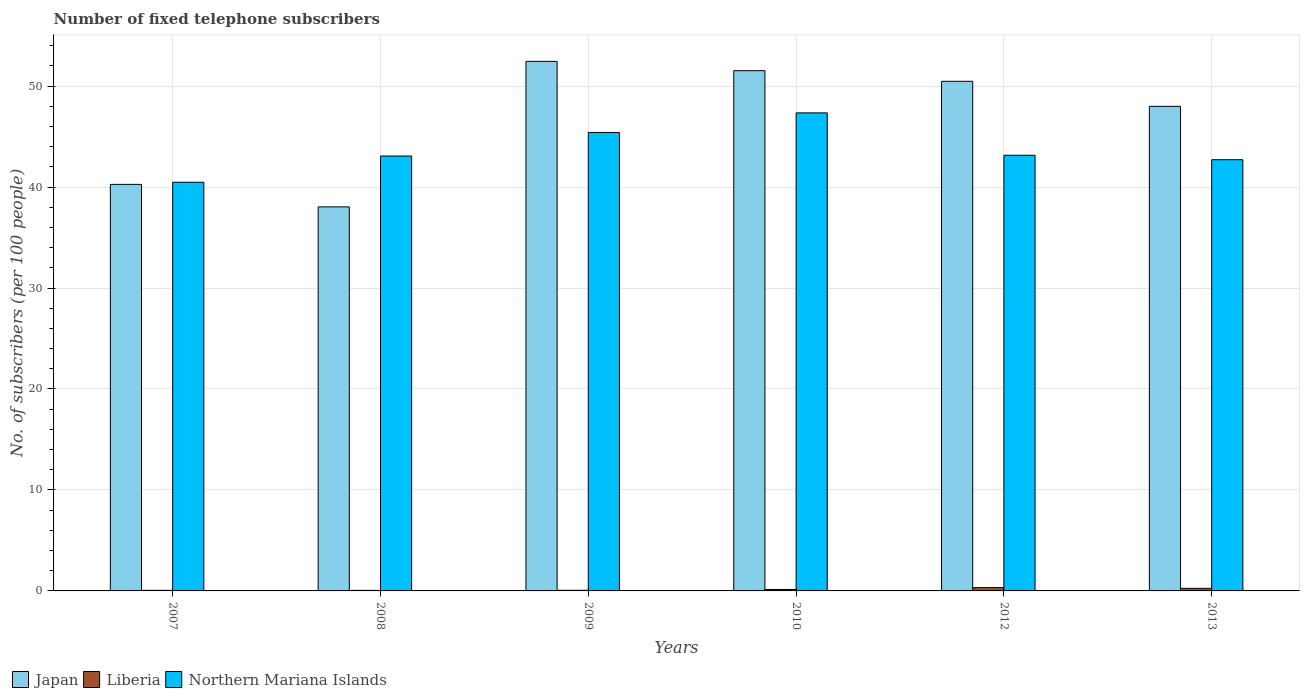How many different coloured bars are there?
Give a very brief answer. 3. How many groups of bars are there?
Make the answer very short. 6. Are the number of bars on each tick of the X-axis equal?
Keep it short and to the point. Yes. How many bars are there on the 3rd tick from the right?
Keep it short and to the point. 3. What is the number of fixed telephone subscribers in Northern Mariana Islands in 2012?
Offer a very short reply. 43.15. Across all years, what is the maximum number of fixed telephone subscribers in Japan?
Ensure brevity in your answer.  52.45. Across all years, what is the minimum number of fixed telephone subscribers in Liberia?
Provide a short and direct response. 0.05. In which year was the number of fixed telephone subscribers in Japan maximum?
Your response must be concise. 2009. In which year was the number of fixed telephone subscribers in Japan minimum?
Your response must be concise. 2008. What is the total number of fixed telephone subscribers in Liberia in the graph?
Provide a short and direct response. 0.91. What is the difference between the number of fixed telephone subscribers in Japan in 2007 and that in 2008?
Offer a very short reply. 2.23. What is the difference between the number of fixed telephone subscribers in Liberia in 2008 and the number of fixed telephone subscribers in Northern Mariana Islands in 2009?
Provide a short and direct response. -45.35. What is the average number of fixed telephone subscribers in Liberia per year?
Offer a very short reply. 0.15. In the year 2010, what is the difference between the number of fixed telephone subscribers in Japan and number of fixed telephone subscribers in Northern Mariana Islands?
Your answer should be compact. 4.18. In how many years, is the number of fixed telephone subscribers in Japan greater than 18?
Keep it short and to the point. 6. What is the ratio of the number of fixed telephone subscribers in Northern Mariana Islands in 2007 to that in 2010?
Make the answer very short. 0.85. Is the number of fixed telephone subscribers in Northern Mariana Islands in 2008 less than that in 2009?
Your response must be concise. Yes. Is the difference between the number of fixed telephone subscribers in Japan in 2008 and 2010 greater than the difference between the number of fixed telephone subscribers in Northern Mariana Islands in 2008 and 2010?
Provide a short and direct response. No. What is the difference between the highest and the second highest number of fixed telephone subscribers in Japan?
Offer a very short reply. 0.92. What is the difference between the highest and the lowest number of fixed telephone subscribers in Northern Mariana Islands?
Offer a terse response. 6.87. In how many years, is the number of fixed telephone subscribers in Japan greater than the average number of fixed telephone subscribers in Japan taken over all years?
Ensure brevity in your answer.  4. Is the sum of the number of fixed telephone subscribers in Northern Mariana Islands in 2008 and 2012 greater than the maximum number of fixed telephone subscribers in Japan across all years?
Provide a short and direct response. Yes. What does the 2nd bar from the left in 2012 represents?
Provide a short and direct response. Liberia. What does the 2nd bar from the right in 2007 represents?
Give a very brief answer. Liberia. Are all the bars in the graph horizontal?
Provide a succinct answer. No. What is the difference between two consecutive major ticks on the Y-axis?
Offer a very short reply. 10. Does the graph contain grids?
Make the answer very short. Yes. Where does the legend appear in the graph?
Your response must be concise. Bottom left. How are the legend labels stacked?
Give a very brief answer. Horizontal. What is the title of the graph?
Your answer should be very brief. Number of fixed telephone subscribers. What is the label or title of the Y-axis?
Your response must be concise. No. of subscribers (per 100 people). What is the No. of subscribers (per 100 people) in Japan in 2007?
Your answer should be compact. 40.26. What is the No. of subscribers (per 100 people) in Liberia in 2007?
Offer a very short reply. 0.06. What is the No. of subscribers (per 100 people) of Northern Mariana Islands in 2007?
Your answer should be compact. 40.47. What is the No. of subscribers (per 100 people) of Japan in 2008?
Make the answer very short. 38.04. What is the No. of subscribers (per 100 people) in Liberia in 2008?
Keep it short and to the point. 0.05. What is the No. of subscribers (per 100 people) of Northern Mariana Islands in 2008?
Your answer should be very brief. 43.07. What is the No. of subscribers (per 100 people) of Japan in 2009?
Keep it short and to the point. 52.45. What is the No. of subscribers (per 100 people) in Liberia in 2009?
Offer a very short reply. 0.06. What is the No. of subscribers (per 100 people) of Northern Mariana Islands in 2009?
Provide a succinct answer. 45.41. What is the No. of subscribers (per 100 people) in Japan in 2010?
Give a very brief answer. 51.53. What is the No. of subscribers (per 100 people) in Liberia in 2010?
Your response must be concise. 0.15. What is the No. of subscribers (per 100 people) in Northern Mariana Islands in 2010?
Your answer should be very brief. 47.34. What is the No. of subscribers (per 100 people) in Japan in 2012?
Offer a very short reply. 50.47. What is the No. of subscribers (per 100 people) in Liberia in 2012?
Your answer should be compact. 0.33. What is the No. of subscribers (per 100 people) in Northern Mariana Islands in 2012?
Keep it short and to the point. 43.15. What is the No. of subscribers (per 100 people) in Japan in 2013?
Your response must be concise. 47.99. What is the No. of subscribers (per 100 people) of Liberia in 2013?
Offer a terse response. 0.26. What is the No. of subscribers (per 100 people) in Northern Mariana Islands in 2013?
Your answer should be very brief. 42.71. Across all years, what is the maximum No. of subscribers (per 100 people) in Japan?
Your answer should be very brief. 52.45. Across all years, what is the maximum No. of subscribers (per 100 people) in Liberia?
Make the answer very short. 0.33. Across all years, what is the maximum No. of subscribers (per 100 people) in Northern Mariana Islands?
Your answer should be very brief. 47.34. Across all years, what is the minimum No. of subscribers (per 100 people) in Japan?
Offer a terse response. 38.04. Across all years, what is the minimum No. of subscribers (per 100 people) in Liberia?
Offer a very short reply. 0.05. Across all years, what is the minimum No. of subscribers (per 100 people) of Northern Mariana Islands?
Keep it short and to the point. 40.47. What is the total No. of subscribers (per 100 people) in Japan in the graph?
Offer a terse response. 280.74. What is the total No. of subscribers (per 100 people) of Liberia in the graph?
Your answer should be very brief. 0.91. What is the total No. of subscribers (per 100 people) of Northern Mariana Islands in the graph?
Keep it short and to the point. 262.15. What is the difference between the No. of subscribers (per 100 people) of Japan in 2007 and that in 2008?
Offer a very short reply. 2.23. What is the difference between the No. of subscribers (per 100 people) in Liberia in 2007 and that in 2008?
Offer a very short reply. 0. What is the difference between the No. of subscribers (per 100 people) of Northern Mariana Islands in 2007 and that in 2008?
Provide a succinct answer. -2.6. What is the difference between the No. of subscribers (per 100 people) in Japan in 2007 and that in 2009?
Ensure brevity in your answer.  -12.18. What is the difference between the No. of subscribers (per 100 people) of Liberia in 2007 and that in 2009?
Make the answer very short. -0. What is the difference between the No. of subscribers (per 100 people) of Northern Mariana Islands in 2007 and that in 2009?
Give a very brief answer. -4.93. What is the difference between the No. of subscribers (per 100 people) in Japan in 2007 and that in 2010?
Your answer should be very brief. -11.26. What is the difference between the No. of subscribers (per 100 people) of Liberia in 2007 and that in 2010?
Offer a terse response. -0.09. What is the difference between the No. of subscribers (per 100 people) in Northern Mariana Islands in 2007 and that in 2010?
Your answer should be compact. -6.87. What is the difference between the No. of subscribers (per 100 people) of Japan in 2007 and that in 2012?
Ensure brevity in your answer.  -10.21. What is the difference between the No. of subscribers (per 100 people) of Liberia in 2007 and that in 2012?
Provide a short and direct response. -0.27. What is the difference between the No. of subscribers (per 100 people) of Northern Mariana Islands in 2007 and that in 2012?
Your answer should be very brief. -2.67. What is the difference between the No. of subscribers (per 100 people) in Japan in 2007 and that in 2013?
Offer a terse response. -7.73. What is the difference between the No. of subscribers (per 100 people) in Liberia in 2007 and that in 2013?
Keep it short and to the point. -0.2. What is the difference between the No. of subscribers (per 100 people) in Northern Mariana Islands in 2007 and that in 2013?
Offer a terse response. -2.23. What is the difference between the No. of subscribers (per 100 people) in Japan in 2008 and that in 2009?
Your response must be concise. -14.41. What is the difference between the No. of subscribers (per 100 people) of Liberia in 2008 and that in 2009?
Give a very brief answer. -0.01. What is the difference between the No. of subscribers (per 100 people) of Northern Mariana Islands in 2008 and that in 2009?
Make the answer very short. -2.33. What is the difference between the No. of subscribers (per 100 people) of Japan in 2008 and that in 2010?
Offer a terse response. -13.49. What is the difference between the No. of subscribers (per 100 people) in Liberia in 2008 and that in 2010?
Your response must be concise. -0.09. What is the difference between the No. of subscribers (per 100 people) of Northern Mariana Islands in 2008 and that in 2010?
Provide a succinct answer. -4.27. What is the difference between the No. of subscribers (per 100 people) of Japan in 2008 and that in 2012?
Keep it short and to the point. -12.44. What is the difference between the No. of subscribers (per 100 people) of Liberia in 2008 and that in 2012?
Your answer should be compact. -0.27. What is the difference between the No. of subscribers (per 100 people) in Northern Mariana Islands in 2008 and that in 2012?
Keep it short and to the point. -0.08. What is the difference between the No. of subscribers (per 100 people) of Japan in 2008 and that in 2013?
Offer a terse response. -9.96. What is the difference between the No. of subscribers (per 100 people) in Liberia in 2008 and that in 2013?
Your answer should be compact. -0.2. What is the difference between the No. of subscribers (per 100 people) in Northern Mariana Islands in 2008 and that in 2013?
Provide a short and direct response. 0.37. What is the difference between the No. of subscribers (per 100 people) of Japan in 2009 and that in 2010?
Your response must be concise. 0.92. What is the difference between the No. of subscribers (per 100 people) in Liberia in 2009 and that in 2010?
Ensure brevity in your answer.  -0.08. What is the difference between the No. of subscribers (per 100 people) in Northern Mariana Islands in 2009 and that in 2010?
Your response must be concise. -1.94. What is the difference between the No. of subscribers (per 100 people) of Japan in 2009 and that in 2012?
Your response must be concise. 1.98. What is the difference between the No. of subscribers (per 100 people) in Liberia in 2009 and that in 2012?
Your answer should be very brief. -0.27. What is the difference between the No. of subscribers (per 100 people) in Northern Mariana Islands in 2009 and that in 2012?
Make the answer very short. 2.26. What is the difference between the No. of subscribers (per 100 people) of Japan in 2009 and that in 2013?
Your answer should be compact. 4.46. What is the difference between the No. of subscribers (per 100 people) of Liberia in 2009 and that in 2013?
Ensure brevity in your answer.  -0.19. What is the difference between the No. of subscribers (per 100 people) in Northern Mariana Islands in 2009 and that in 2013?
Keep it short and to the point. 2.7. What is the difference between the No. of subscribers (per 100 people) of Japan in 2010 and that in 2012?
Offer a terse response. 1.05. What is the difference between the No. of subscribers (per 100 people) in Liberia in 2010 and that in 2012?
Offer a very short reply. -0.18. What is the difference between the No. of subscribers (per 100 people) of Northern Mariana Islands in 2010 and that in 2012?
Keep it short and to the point. 4.2. What is the difference between the No. of subscribers (per 100 people) in Japan in 2010 and that in 2013?
Give a very brief answer. 3.53. What is the difference between the No. of subscribers (per 100 people) of Liberia in 2010 and that in 2013?
Your answer should be compact. -0.11. What is the difference between the No. of subscribers (per 100 people) in Northern Mariana Islands in 2010 and that in 2013?
Your response must be concise. 4.64. What is the difference between the No. of subscribers (per 100 people) of Japan in 2012 and that in 2013?
Ensure brevity in your answer.  2.48. What is the difference between the No. of subscribers (per 100 people) in Liberia in 2012 and that in 2013?
Make the answer very short. 0.07. What is the difference between the No. of subscribers (per 100 people) in Northern Mariana Islands in 2012 and that in 2013?
Your answer should be very brief. 0.44. What is the difference between the No. of subscribers (per 100 people) in Japan in 2007 and the No. of subscribers (per 100 people) in Liberia in 2008?
Ensure brevity in your answer.  40.21. What is the difference between the No. of subscribers (per 100 people) in Japan in 2007 and the No. of subscribers (per 100 people) in Northern Mariana Islands in 2008?
Provide a succinct answer. -2.81. What is the difference between the No. of subscribers (per 100 people) of Liberia in 2007 and the No. of subscribers (per 100 people) of Northern Mariana Islands in 2008?
Make the answer very short. -43.01. What is the difference between the No. of subscribers (per 100 people) in Japan in 2007 and the No. of subscribers (per 100 people) in Liberia in 2009?
Keep it short and to the point. 40.2. What is the difference between the No. of subscribers (per 100 people) of Japan in 2007 and the No. of subscribers (per 100 people) of Northern Mariana Islands in 2009?
Ensure brevity in your answer.  -5.14. What is the difference between the No. of subscribers (per 100 people) of Liberia in 2007 and the No. of subscribers (per 100 people) of Northern Mariana Islands in 2009?
Your answer should be very brief. -45.35. What is the difference between the No. of subscribers (per 100 people) in Japan in 2007 and the No. of subscribers (per 100 people) in Liberia in 2010?
Offer a very short reply. 40.12. What is the difference between the No. of subscribers (per 100 people) in Japan in 2007 and the No. of subscribers (per 100 people) in Northern Mariana Islands in 2010?
Keep it short and to the point. -7.08. What is the difference between the No. of subscribers (per 100 people) of Liberia in 2007 and the No. of subscribers (per 100 people) of Northern Mariana Islands in 2010?
Your answer should be compact. -47.29. What is the difference between the No. of subscribers (per 100 people) in Japan in 2007 and the No. of subscribers (per 100 people) in Liberia in 2012?
Your response must be concise. 39.94. What is the difference between the No. of subscribers (per 100 people) in Japan in 2007 and the No. of subscribers (per 100 people) in Northern Mariana Islands in 2012?
Offer a terse response. -2.88. What is the difference between the No. of subscribers (per 100 people) of Liberia in 2007 and the No. of subscribers (per 100 people) of Northern Mariana Islands in 2012?
Offer a terse response. -43.09. What is the difference between the No. of subscribers (per 100 people) in Japan in 2007 and the No. of subscribers (per 100 people) in Liberia in 2013?
Make the answer very short. 40.01. What is the difference between the No. of subscribers (per 100 people) of Japan in 2007 and the No. of subscribers (per 100 people) of Northern Mariana Islands in 2013?
Your answer should be very brief. -2.44. What is the difference between the No. of subscribers (per 100 people) in Liberia in 2007 and the No. of subscribers (per 100 people) in Northern Mariana Islands in 2013?
Give a very brief answer. -42.65. What is the difference between the No. of subscribers (per 100 people) in Japan in 2008 and the No. of subscribers (per 100 people) in Liberia in 2009?
Offer a terse response. 37.97. What is the difference between the No. of subscribers (per 100 people) of Japan in 2008 and the No. of subscribers (per 100 people) of Northern Mariana Islands in 2009?
Offer a terse response. -7.37. What is the difference between the No. of subscribers (per 100 people) of Liberia in 2008 and the No. of subscribers (per 100 people) of Northern Mariana Islands in 2009?
Your answer should be compact. -45.35. What is the difference between the No. of subscribers (per 100 people) of Japan in 2008 and the No. of subscribers (per 100 people) of Liberia in 2010?
Make the answer very short. 37.89. What is the difference between the No. of subscribers (per 100 people) in Japan in 2008 and the No. of subscribers (per 100 people) in Northern Mariana Islands in 2010?
Keep it short and to the point. -9.31. What is the difference between the No. of subscribers (per 100 people) in Liberia in 2008 and the No. of subscribers (per 100 people) in Northern Mariana Islands in 2010?
Your answer should be very brief. -47.29. What is the difference between the No. of subscribers (per 100 people) of Japan in 2008 and the No. of subscribers (per 100 people) of Liberia in 2012?
Provide a succinct answer. 37.71. What is the difference between the No. of subscribers (per 100 people) in Japan in 2008 and the No. of subscribers (per 100 people) in Northern Mariana Islands in 2012?
Your answer should be very brief. -5.11. What is the difference between the No. of subscribers (per 100 people) in Liberia in 2008 and the No. of subscribers (per 100 people) in Northern Mariana Islands in 2012?
Give a very brief answer. -43.09. What is the difference between the No. of subscribers (per 100 people) of Japan in 2008 and the No. of subscribers (per 100 people) of Liberia in 2013?
Keep it short and to the point. 37.78. What is the difference between the No. of subscribers (per 100 people) in Japan in 2008 and the No. of subscribers (per 100 people) in Northern Mariana Islands in 2013?
Make the answer very short. -4.67. What is the difference between the No. of subscribers (per 100 people) of Liberia in 2008 and the No. of subscribers (per 100 people) of Northern Mariana Islands in 2013?
Offer a terse response. -42.65. What is the difference between the No. of subscribers (per 100 people) in Japan in 2009 and the No. of subscribers (per 100 people) in Liberia in 2010?
Provide a short and direct response. 52.3. What is the difference between the No. of subscribers (per 100 people) of Japan in 2009 and the No. of subscribers (per 100 people) of Northern Mariana Islands in 2010?
Provide a succinct answer. 5.1. What is the difference between the No. of subscribers (per 100 people) in Liberia in 2009 and the No. of subscribers (per 100 people) in Northern Mariana Islands in 2010?
Give a very brief answer. -47.28. What is the difference between the No. of subscribers (per 100 people) of Japan in 2009 and the No. of subscribers (per 100 people) of Liberia in 2012?
Your answer should be very brief. 52.12. What is the difference between the No. of subscribers (per 100 people) of Japan in 2009 and the No. of subscribers (per 100 people) of Northern Mariana Islands in 2012?
Give a very brief answer. 9.3. What is the difference between the No. of subscribers (per 100 people) in Liberia in 2009 and the No. of subscribers (per 100 people) in Northern Mariana Islands in 2012?
Your answer should be compact. -43.09. What is the difference between the No. of subscribers (per 100 people) in Japan in 2009 and the No. of subscribers (per 100 people) in Liberia in 2013?
Keep it short and to the point. 52.19. What is the difference between the No. of subscribers (per 100 people) of Japan in 2009 and the No. of subscribers (per 100 people) of Northern Mariana Islands in 2013?
Offer a very short reply. 9.74. What is the difference between the No. of subscribers (per 100 people) of Liberia in 2009 and the No. of subscribers (per 100 people) of Northern Mariana Islands in 2013?
Offer a terse response. -42.65. What is the difference between the No. of subscribers (per 100 people) of Japan in 2010 and the No. of subscribers (per 100 people) of Liberia in 2012?
Your answer should be compact. 51.2. What is the difference between the No. of subscribers (per 100 people) in Japan in 2010 and the No. of subscribers (per 100 people) in Northern Mariana Islands in 2012?
Offer a very short reply. 8.38. What is the difference between the No. of subscribers (per 100 people) in Liberia in 2010 and the No. of subscribers (per 100 people) in Northern Mariana Islands in 2012?
Provide a succinct answer. -43. What is the difference between the No. of subscribers (per 100 people) of Japan in 2010 and the No. of subscribers (per 100 people) of Liberia in 2013?
Your answer should be compact. 51.27. What is the difference between the No. of subscribers (per 100 people) of Japan in 2010 and the No. of subscribers (per 100 people) of Northern Mariana Islands in 2013?
Provide a succinct answer. 8.82. What is the difference between the No. of subscribers (per 100 people) in Liberia in 2010 and the No. of subscribers (per 100 people) in Northern Mariana Islands in 2013?
Provide a short and direct response. -42.56. What is the difference between the No. of subscribers (per 100 people) of Japan in 2012 and the No. of subscribers (per 100 people) of Liberia in 2013?
Make the answer very short. 50.22. What is the difference between the No. of subscribers (per 100 people) in Japan in 2012 and the No. of subscribers (per 100 people) in Northern Mariana Islands in 2013?
Keep it short and to the point. 7.76. What is the difference between the No. of subscribers (per 100 people) of Liberia in 2012 and the No. of subscribers (per 100 people) of Northern Mariana Islands in 2013?
Your answer should be very brief. -42.38. What is the average No. of subscribers (per 100 people) in Japan per year?
Keep it short and to the point. 46.79. What is the average No. of subscribers (per 100 people) of Liberia per year?
Provide a short and direct response. 0.15. What is the average No. of subscribers (per 100 people) of Northern Mariana Islands per year?
Provide a succinct answer. 43.69. In the year 2007, what is the difference between the No. of subscribers (per 100 people) of Japan and No. of subscribers (per 100 people) of Liberia?
Provide a short and direct response. 40.21. In the year 2007, what is the difference between the No. of subscribers (per 100 people) of Japan and No. of subscribers (per 100 people) of Northern Mariana Islands?
Provide a succinct answer. -0.21. In the year 2007, what is the difference between the No. of subscribers (per 100 people) of Liberia and No. of subscribers (per 100 people) of Northern Mariana Islands?
Offer a very short reply. -40.42. In the year 2008, what is the difference between the No. of subscribers (per 100 people) of Japan and No. of subscribers (per 100 people) of Liberia?
Give a very brief answer. 37.98. In the year 2008, what is the difference between the No. of subscribers (per 100 people) of Japan and No. of subscribers (per 100 people) of Northern Mariana Islands?
Provide a short and direct response. -5.04. In the year 2008, what is the difference between the No. of subscribers (per 100 people) of Liberia and No. of subscribers (per 100 people) of Northern Mariana Islands?
Your response must be concise. -43.02. In the year 2009, what is the difference between the No. of subscribers (per 100 people) of Japan and No. of subscribers (per 100 people) of Liberia?
Your response must be concise. 52.39. In the year 2009, what is the difference between the No. of subscribers (per 100 people) of Japan and No. of subscribers (per 100 people) of Northern Mariana Islands?
Offer a terse response. 7.04. In the year 2009, what is the difference between the No. of subscribers (per 100 people) in Liberia and No. of subscribers (per 100 people) in Northern Mariana Islands?
Give a very brief answer. -45.34. In the year 2010, what is the difference between the No. of subscribers (per 100 people) of Japan and No. of subscribers (per 100 people) of Liberia?
Your answer should be compact. 51.38. In the year 2010, what is the difference between the No. of subscribers (per 100 people) of Japan and No. of subscribers (per 100 people) of Northern Mariana Islands?
Your answer should be compact. 4.18. In the year 2010, what is the difference between the No. of subscribers (per 100 people) in Liberia and No. of subscribers (per 100 people) in Northern Mariana Islands?
Your answer should be very brief. -47.2. In the year 2012, what is the difference between the No. of subscribers (per 100 people) of Japan and No. of subscribers (per 100 people) of Liberia?
Your response must be concise. 50.14. In the year 2012, what is the difference between the No. of subscribers (per 100 people) in Japan and No. of subscribers (per 100 people) in Northern Mariana Islands?
Offer a terse response. 7.32. In the year 2012, what is the difference between the No. of subscribers (per 100 people) of Liberia and No. of subscribers (per 100 people) of Northern Mariana Islands?
Ensure brevity in your answer.  -42.82. In the year 2013, what is the difference between the No. of subscribers (per 100 people) in Japan and No. of subscribers (per 100 people) in Liberia?
Offer a terse response. 47.74. In the year 2013, what is the difference between the No. of subscribers (per 100 people) of Japan and No. of subscribers (per 100 people) of Northern Mariana Islands?
Your answer should be compact. 5.28. In the year 2013, what is the difference between the No. of subscribers (per 100 people) in Liberia and No. of subscribers (per 100 people) in Northern Mariana Islands?
Your answer should be compact. -42.45. What is the ratio of the No. of subscribers (per 100 people) of Japan in 2007 to that in 2008?
Offer a terse response. 1.06. What is the ratio of the No. of subscribers (per 100 people) of Liberia in 2007 to that in 2008?
Give a very brief answer. 1.07. What is the ratio of the No. of subscribers (per 100 people) in Northern Mariana Islands in 2007 to that in 2008?
Give a very brief answer. 0.94. What is the ratio of the No. of subscribers (per 100 people) of Japan in 2007 to that in 2009?
Offer a very short reply. 0.77. What is the ratio of the No. of subscribers (per 100 people) in Liberia in 2007 to that in 2009?
Your response must be concise. 0.94. What is the ratio of the No. of subscribers (per 100 people) of Northern Mariana Islands in 2007 to that in 2009?
Provide a short and direct response. 0.89. What is the ratio of the No. of subscribers (per 100 people) of Japan in 2007 to that in 2010?
Your answer should be compact. 0.78. What is the ratio of the No. of subscribers (per 100 people) in Liberia in 2007 to that in 2010?
Your answer should be compact. 0.4. What is the ratio of the No. of subscribers (per 100 people) in Northern Mariana Islands in 2007 to that in 2010?
Offer a terse response. 0.85. What is the ratio of the No. of subscribers (per 100 people) of Japan in 2007 to that in 2012?
Provide a succinct answer. 0.8. What is the ratio of the No. of subscribers (per 100 people) in Liberia in 2007 to that in 2012?
Offer a terse response. 0.18. What is the ratio of the No. of subscribers (per 100 people) of Northern Mariana Islands in 2007 to that in 2012?
Your answer should be very brief. 0.94. What is the ratio of the No. of subscribers (per 100 people) of Japan in 2007 to that in 2013?
Give a very brief answer. 0.84. What is the ratio of the No. of subscribers (per 100 people) of Liberia in 2007 to that in 2013?
Provide a short and direct response. 0.23. What is the ratio of the No. of subscribers (per 100 people) of Northern Mariana Islands in 2007 to that in 2013?
Your response must be concise. 0.95. What is the ratio of the No. of subscribers (per 100 people) in Japan in 2008 to that in 2009?
Provide a succinct answer. 0.73. What is the ratio of the No. of subscribers (per 100 people) in Liberia in 2008 to that in 2009?
Keep it short and to the point. 0.88. What is the ratio of the No. of subscribers (per 100 people) of Northern Mariana Islands in 2008 to that in 2009?
Your answer should be compact. 0.95. What is the ratio of the No. of subscribers (per 100 people) in Japan in 2008 to that in 2010?
Make the answer very short. 0.74. What is the ratio of the No. of subscribers (per 100 people) of Liberia in 2008 to that in 2010?
Ensure brevity in your answer.  0.37. What is the ratio of the No. of subscribers (per 100 people) in Northern Mariana Islands in 2008 to that in 2010?
Provide a succinct answer. 0.91. What is the ratio of the No. of subscribers (per 100 people) in Japan in 2008 to that in 2012?
Your answer should be compact. 0.75. What is the ratio of the No. of subscribers (per 100 people) of Liberia in 2008 to that in 2012?
Your answer should be compact. 0.17. What is the ratio of the No. of subscribers (per 100 people) of Northern Mariana Islands in 2008 to that in 2012?
Ensure brevity in your answer.  1. What is the ratio of the No. of subscribers (per 100 people) of Japan in 2008 to that in 2013?
Your response must be concise. 0.79. What is the ratio of the No. of subscribers (per 100 people) in Liberia in 2008 to that in 2013?
Ensure brevity in your answer.  0.21. What is the ratio of the No. of subscribers (per 100 people) of Northern Mariana Islands in 2008 to that in 2013?
Your answer should be compact. 1.01. What is the ratio of the No. of subscribers (per 100 people) in Japan in 2009 to that in 2010?
Give a very brief answer. 1.02. What is the ratio of the No. of subscribers (per 100 people) of Liberia in 2009 to that in 2010?
Your answer should be very brief. 0.42. What is the ratio of the No. of subscribers (per 100 people) of Northern Mariana Islands in 2009 to that in 2010?
Ensure brevity in your answer.  0.96. What is the ratio of the No. of subscribers (per 100 people) of Japan in 2009 to that in 2012?
Your answer should be compact. 1.04. What is the ratio of the No. of subscribers (per 100 people) in Liberia in 2009 to that in 2012?
Provide a succinct answer. 0.19. What is the ratio of the No. of subscribers (per 100 people) of Northern Mariana Islands in 2009 to that in 2012?
Provide a short and direct response. 1.05. What is the ratio of the No. of subscribers (per 100 people) in Japan in 2009 to that in 2013?
Offer a very short reply. 1.09. What is the ratio of the No. of subscribers (per 100 people) in Liberia in 2009 to that in 2013?
Offer a terse response. 0.24. What is the ratio of the No. of subscribers (per 100 people) of Northern Mariana Islands in 2009 to that in 2013?
Your answer should be very brief. 1.06. What is the ratio of the No. of subscribers (per 100 people) of Japan in 2010 to that in 2012?
Your answer should be compact. 1.02. What is the ratio of the No. of subscribers (per 100 people) of Liberia in 2010 to that in 2012?
Make the answer very short. 0.45. What is the ratio of the No. of subscribers (per 100 people) of Northern Mariana Islands in 2010 to that in 2012?
Offer a very short reply. 1.1. What is the ratio of the No. of subscribers (per 100 people) of Japan in 2010 to that in 2013?
Your answer should be compact. 1.07. What is the ratio of the No. of subscribers (per 100 people) in Liberia in 2010 to that in 2013?
Your answer should be compact. 0.57. What is the ratio of the No. of subscribers (per 100 people) in Northern Mariana Islands in 2010 to that in 2013?
Your answer should be very brief. 1.11. What is the ratio of the No. of subscribers (per 100 people) of Japan in 2012 to that in 2013?
Make the answer very short. 1.05. What is the ratio of the No. of subscribers (per 100 people) of Liberia in 2012 to that in 2013?
Give a very brief answer. 1.28. What is the ratio of the No. of subscribers (per 100 people) in Northern Mariana Islands in 2012 to that in 2013?
Offer a very short reply. 1.01. What is the difference between the highest and the second highest No. of subscribers (per 100 people) in Japan?
Ensure brevity in your answer.  0.92. What is the difference between the highest and the second highest No. of subscribers (per 100 people) in Liberia?
Provide a short and direct response. 0.07. What is the difference between the highest and the second highest No. of subscribers (per 100 people) in Northern Mariana Islands?
Offer a very short reply. 1.94. What is the difference between the highest and the lowest No. of subscribers (per 100 people) of Japan?
Offer a very short reply. 14.41. What is the difference between the highest and the lowest No. of subscribers (per 100 people) of Liberia?
Offer a terse response. 0.27. What is the difference between the highest and the lowest No. of subscribers (per 100 people) of Northern Mariana Islands?
Give a very brief answer. 6.87. 